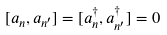<formula> <loc_0><loc_0><loc_500><loc_500>[ a _ { n } , a _ { n ^ { \prime } } ] = [ a ^ { \dagger } _ { n } , a ^ { \dagger } _ { n ^ { \prime } } ] = 0</formula> 